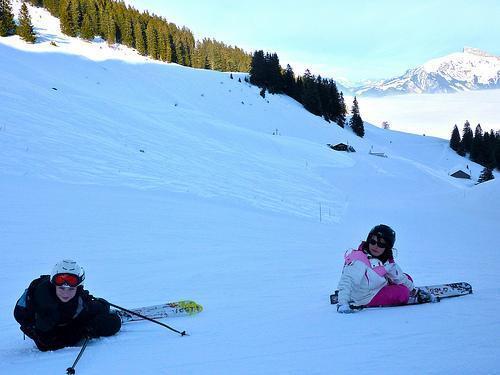How many people in the photo?
Give a very brief answer. 2. How many people are there?
Give a very brief answer. 2. 